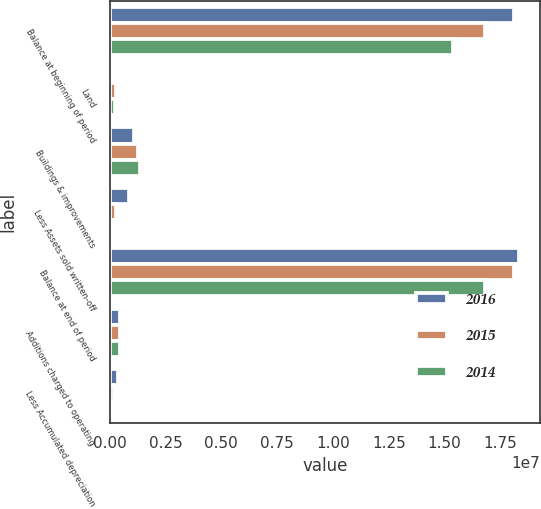Convert chart to OTSL. <chart><loc_0><loc_0><loc_500><loc_500><stacked_bar_chart><ecel><fcel>Balance at beginning of period<fcel>Land<fcel>Buildings & improvements<fcel>Less Assets sold written-off<fcel>Balance at end of period<fcel>Additions charged to operating<fcel>Less Accumulated depreciation<nl><fcel>2016<fcel>1.80901e+07<fcel>30805<fcel>1.07426e+06<fcel>855243<fcel>1.834e+07<fcel>478788<fcel>383481<nl><fcel>2015<fcel>1.68224e+07<fcel>281048<fcel>1.28814e+06<fcel>301405<fcel>1.80901e+07<fcel>459612<fcel>202978<nl><fcel>2014<fcel>1.5393e+07<fcel>225536<fcel>1.34815e+06<fcel>144299<fcel>1.68224e+07<fcel>461689<fcel>129918<nl></chart> 